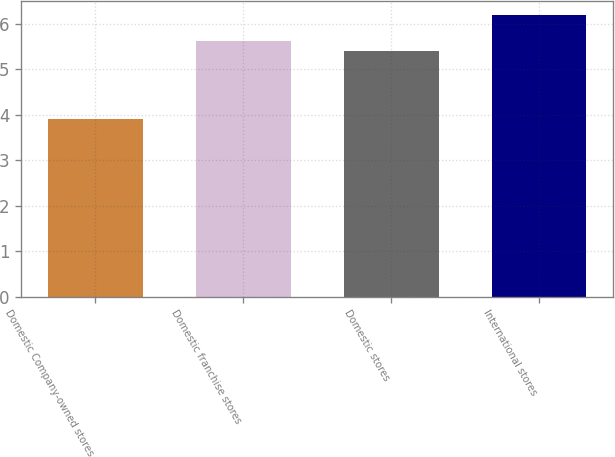Convert chart to OTSL. <chart><loc_0><loc_0><loc_500><loc_500><bar_chart><fcel>Domestic Company-owned stores<fcel>Domestic franchise stores<fcel>Domestic stores<fcel>International stores<nl><fcel>3.9<fcel>5.63<fcel>5.4<fcel>6.2<nl></chart> 